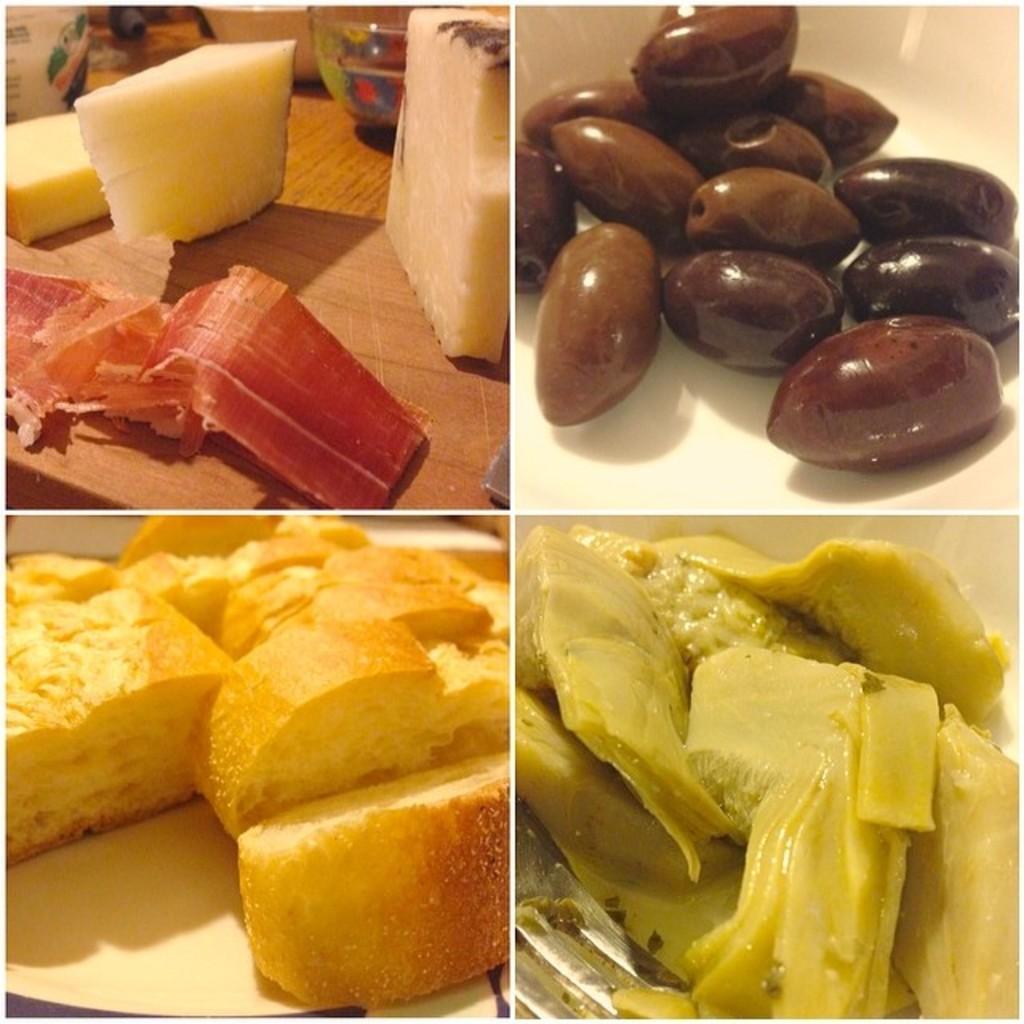Can you describe this image briefly? This image is a collage. In this image we can see different varieties of foods on different images. 